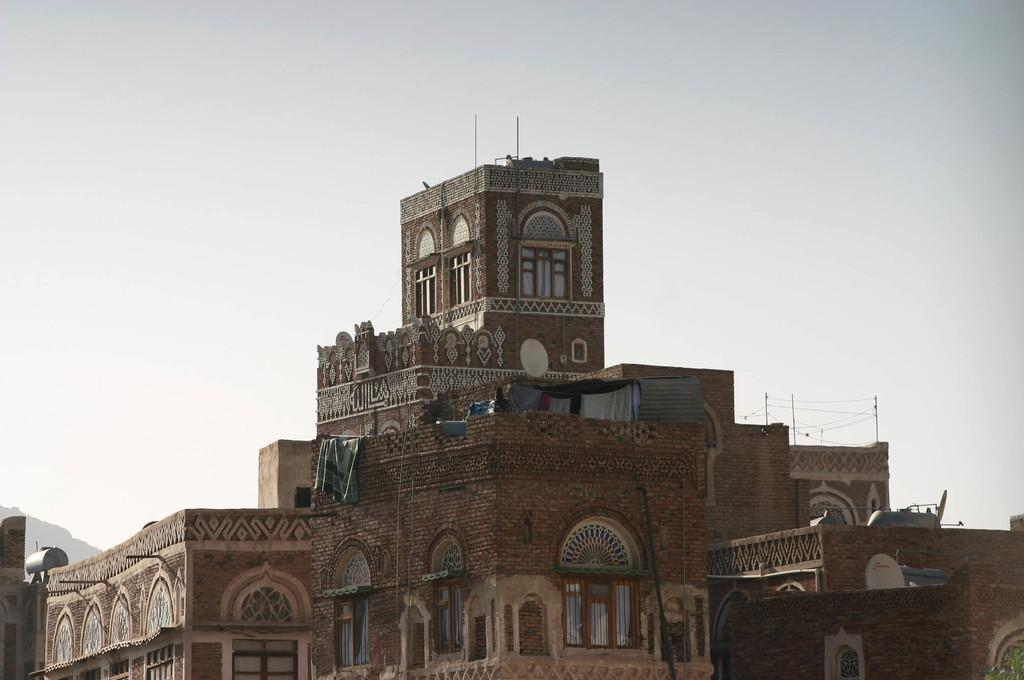What structures are located in the foreground of the image? There are buildings in the foreground of the image. What is visible at the top of the image? The sky is visible at the top of the image. What type of government is depicted in the image? There is no indication of a government in the image; it features buildings and the sky. What can be used to cut materials in the image? There are no scissors or cutting tools present in the image. 